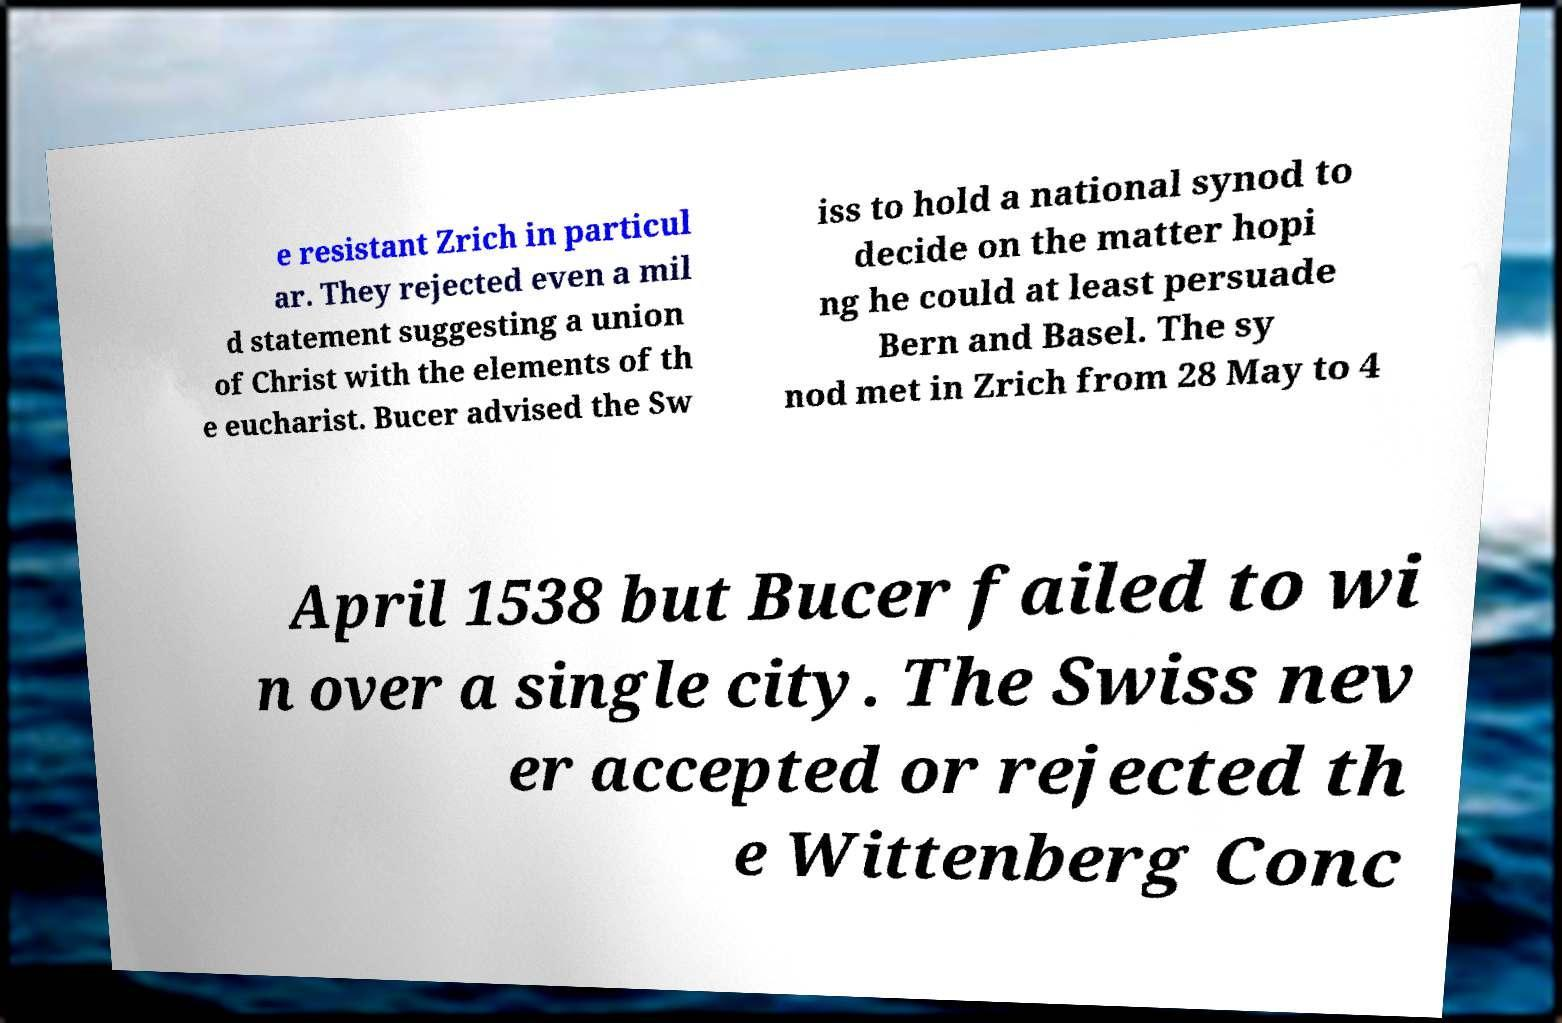Please read and relay the text visible in this image. What does it say? e resistant Zrich in particul ar. They rejected even a mil d statement suggesting a union of Christ with the elements of th e eucharist. Bucer advised the Sw iss to hold a national synod to decide on the matter hopi ng he could at least persuade Bern and Basel. The sy nod met in Zrich from 28 May to 4 April 1538 but Bucer failed to wi n over a single city. The Swiss nev er accepted or rejected th e Wittenberg Conc 